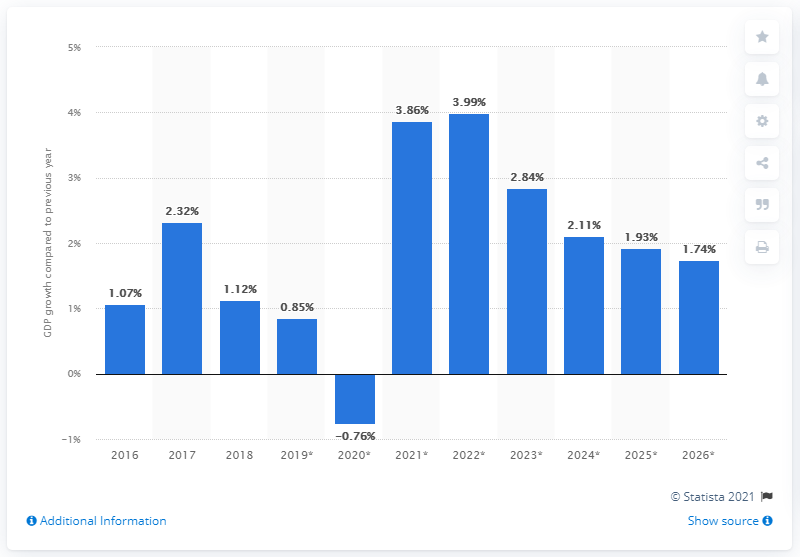Specify some key components in this picture. In 2018, Norway's gross domestic product (GDP) grew by 1.12%. 